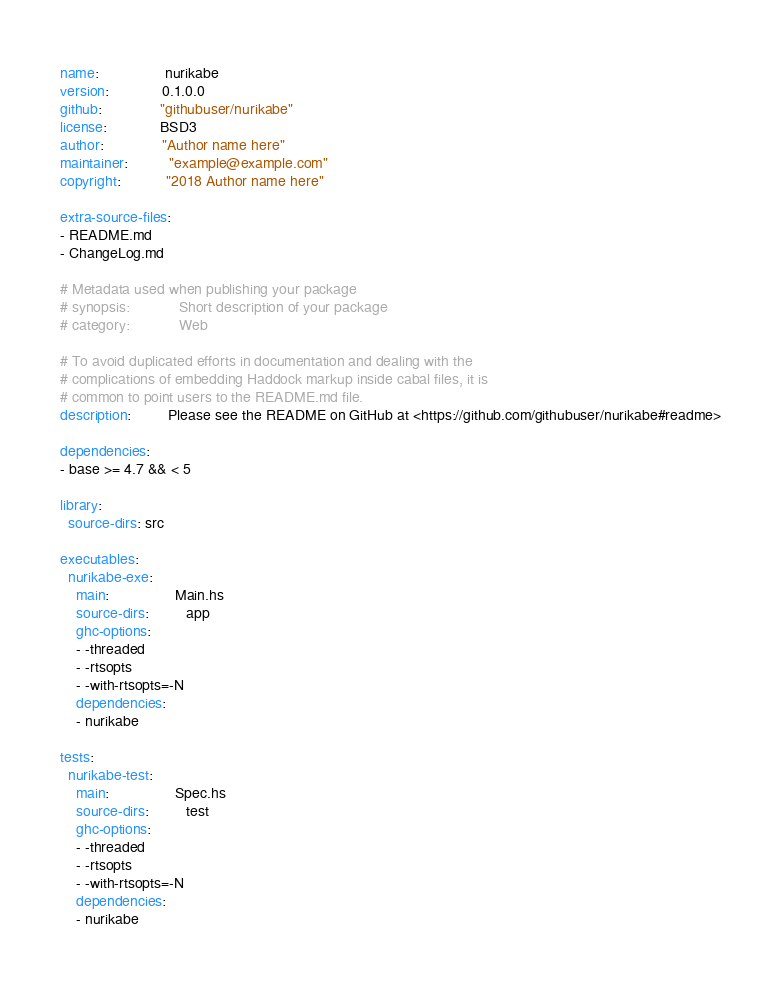Convert code to text. <code><loc_0><loc_0><loc_500><loc_500><_YAML_>name:                nurikabe
version:             0.1.0.0
github:              "githubuser/nurikabe"
license:             BSD3
author:              "Author name here"
maintainer:          "example@example.com"
copyright:           "2018 Author name here"

extra-source-files:
- README.md
- ChangeLog.md

# Metadata used when publishing your package
# synopsis:            Short description of your package
# category:            Web

# To avoid duplicated efforts in documentation and dealing with the
# complications of embedding Haddock markup inside cabal files, it is
# common to point users to the README.md file.
description:         Please see the README on GitHub at <https://github.com/githubuser/nurikabe#readme>

dependencies:
- base >= 4.7 && < 5

library:
  source-dirs: src

executables:
  nurikabe-exe:
    main:                Main.hs
    source-dirs:         app
    ghc-options:
    - -threaded
    - -rtsopts
    - -with-rtsopts=-N
    dependencies:
    - nurikabe

tests:
  nurikabe-test:
    main:                Spec.hs
    source-dirs:         test
    ghc-options:
    - -threaded
    - -rtsopts
    - -with-rtsopts=-N
    dependencies:
    - nurikabe
</code> 